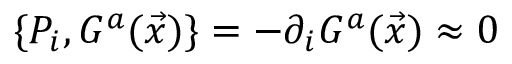Convert formula to latex. <formula><loc_0><loc_0><loc_500><loc_500>\{ P _ { i } , G ^ { a } ( \vec { x } ) \} = - \partial _ { i } G ^ { a } ( \vec { x } ) \approx 0</formula> 